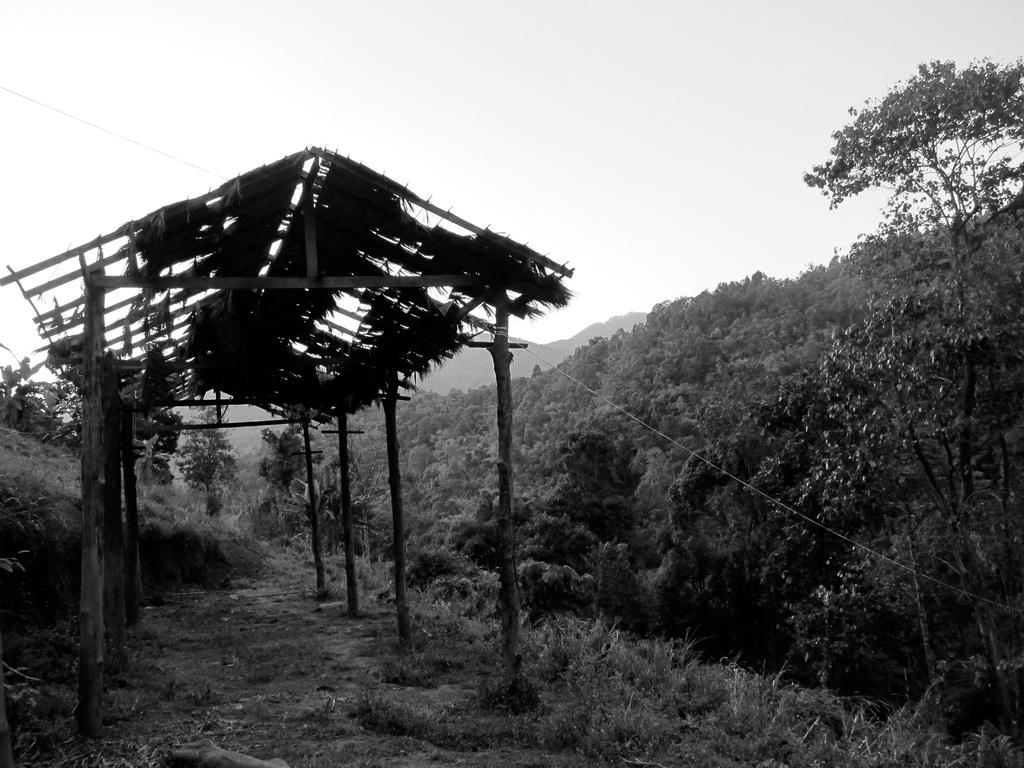What type of structure can be seen on the left side of the image? There is a shed in the image. What other natural elements are present in the image? There are a few trees in the image. How are the shed and trees arranged in the image? The shed and trees are arranged from left to right in the image. What type of credit is being offered to the governor in the image? There is no mention of credit or a governor in the image; it features a shed and trees arranged from left to right. 